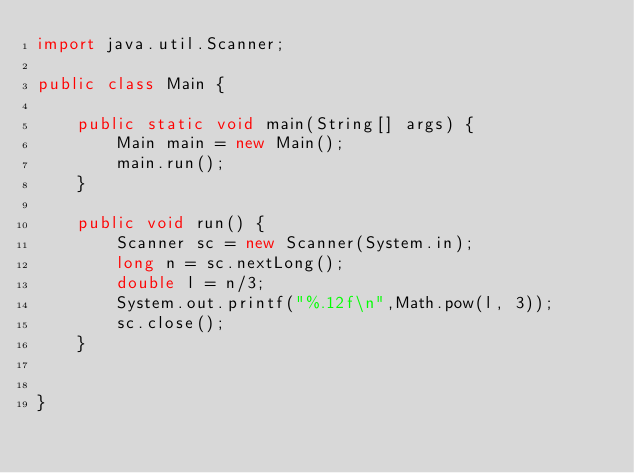<code> <loc_0><loc_0><loc_500><loc_500><_Java_>import java.util.Scanner;

public class Main {

	public static void main(String[] args) {
		Main main = new Main();
		main.run();
	}

	public void run() {
		Scanner sc = new Scanner(System.in);
		long n = sc.nextLong();
		double l = n/3;
		System.out.printf("%.12f\n",Math.pow(l, 3));
		sc.close();
	}


}
</code> 